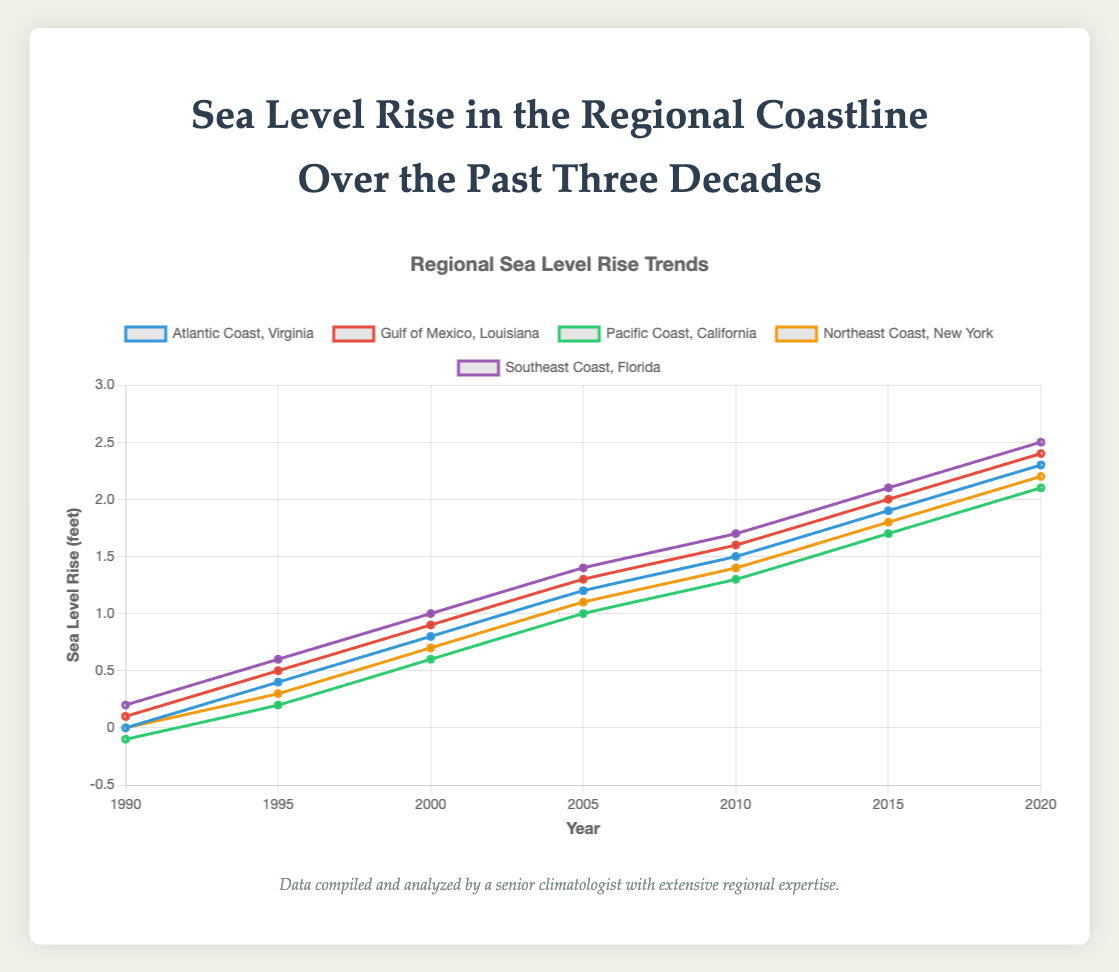What is the general trend of sea level rise from 1990 to 2020 for all locations? Each location shows a general upward trend in sea level rise from 1990 to 2020. For instance, in 1990, the sea level was 0 feet for Atlantic Coast, Virginia, and increased steadily up to 2.3 feet by 2020.
Answer: upward trend Which location experienced the highest sea level rise in 2020? In 2020, the sea level rise at the Southeast Coast, Florida was the highest among all locations, reaching 2.5 feet.
Answer: Southeast Coast, Florida Between 2010 and 2015, which location had the greatest increase in sea level rise? The Gulf of Mexico, Louisiana had the greatest increase in sea level rise from 1.6 feet in 2010 to 2.0 feet in 2015, showing a rise of 0.4 feet.
Answer: Gulf of Mexico, Louisiana What is the average sea level rise in 2020 across all locations? The sea level rise values for 2020 are 2.3, 2.4, 2.1, 2.2, and 2.5 feet. Summing these values gives 11.5 feet. Dividing by 5 (the number of locations), we get an average of 2.3 feet.
Answer: 2.3 feet Compare the sea level rise in 2005 between the Gulf of Mexico, Louisiana, and the Northeast Coast, New York. Which location had a higher rise? In 2005, the Gulf of Mexico, Louisiana had a sea level rise of 1.3 feet, while the Northeast Coast, New York had a rise of 1.1 feet. Therefore, the Gulf of Mexico, Louisiana had a higher rise.
Answer: Gulf of Mexico, Louisiana Which year saw the largest increase in sea level rise for the Pacific Coast, California from the previous year reported? The Pacific Coast, California saw the largest increase from 0.6 feet in 2000 to 1.0 feet in 2005, an increase of 0.4 feet.
Answer: 2005 Identify the year and location with the smallest sea level rise in the entire dataset. In 1990, the Pacific Coast, California had the smallest sea level rise at -0.1 feet.
Answer: 1990, Pacific Coast, California How does the sea level rise in 2020 for the Atlantic Coast, Virginia compare to that in 1990? The sea level rise for the Atlantic Coast, Virginia increased from 0.0 feet in 1990 to 2.3 feet in 2020.
Answer: increased What color represents the sea level data for the Southeast Coast, Florida in the plot? The color representing the Southeast Coast, Florida in the plot is purple.
Answer: purple Which location had a constant sea level rise from 1990 to 1995 and by how much did it increase? The Atlantic Coast, Virginia had a constant increase in sea level rise of 0.4 feet, from 0.0 feet in 1990 to 0.4 feet in 1995.
Answer: Atlantic Coast, Virginia, 0.4 feet 